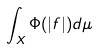<formula> <loc_0><loc_0><loc_500><loc_500>\int _ { X } \Phi ( | f | ) d \mu</formula> 